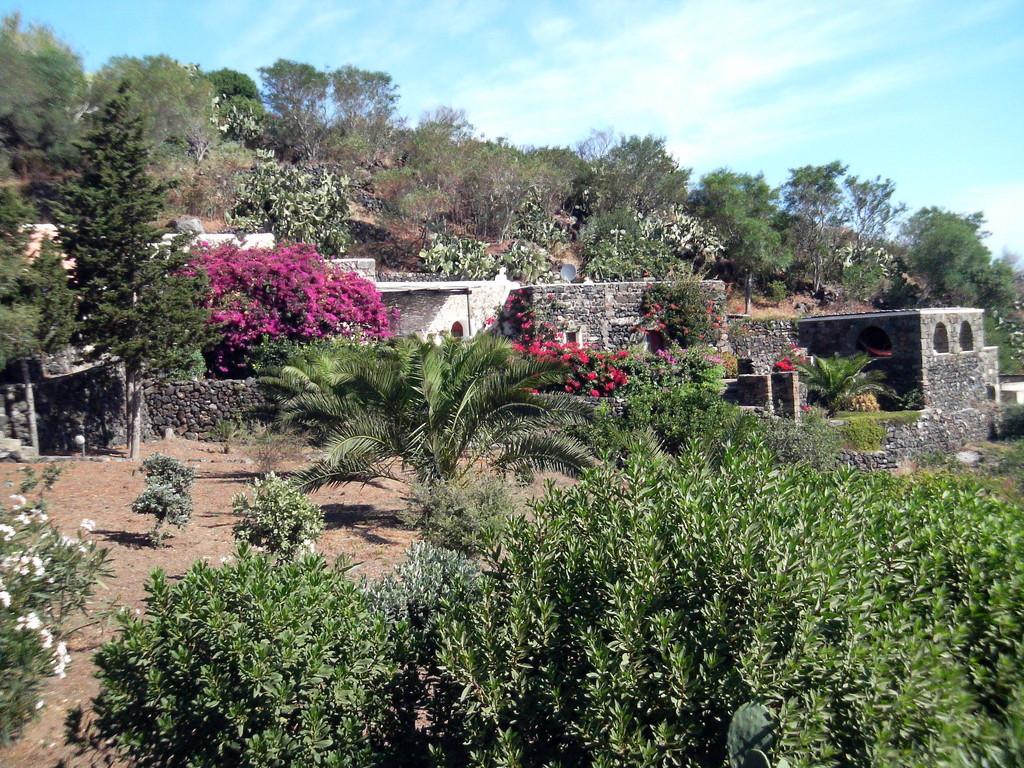In one or two sentences, can you explain what this image depicts? In this image we can see the building on the ground. And there are trees, plants with flowers and the sky. 